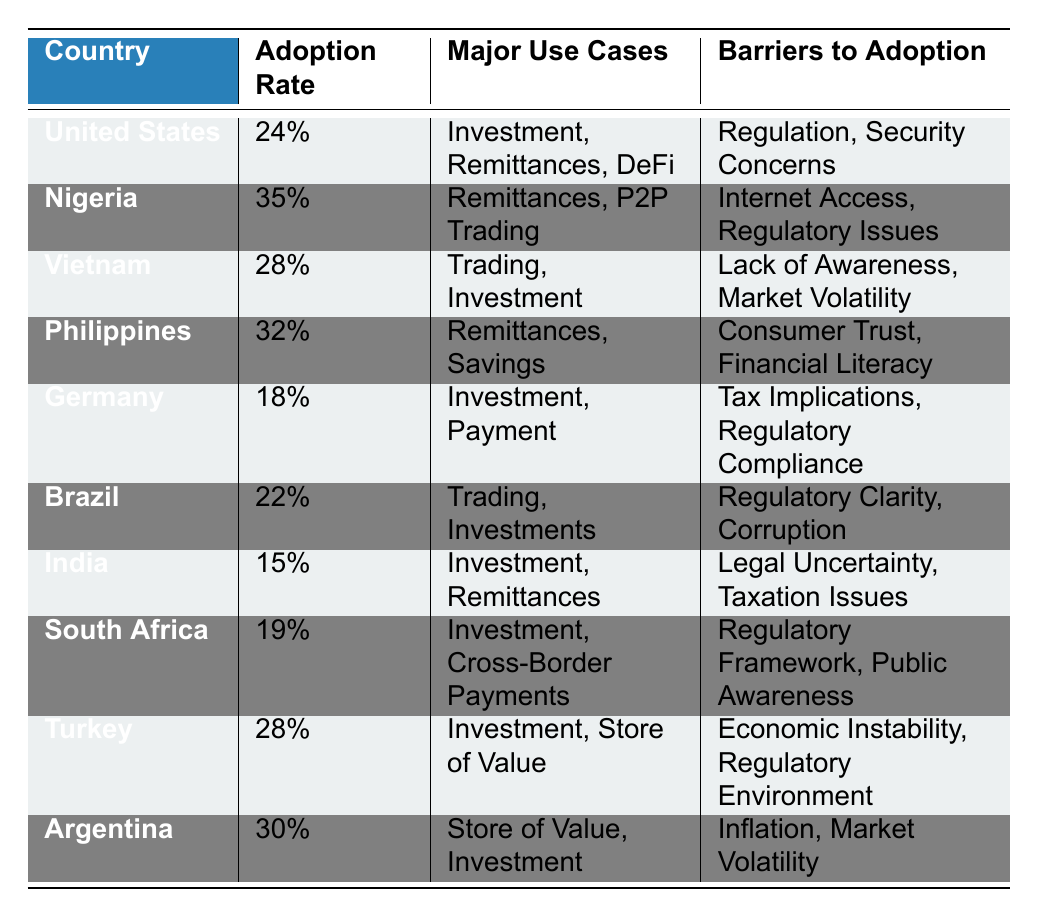What is the adoption rate of Nigeria? According to the table, Nigeria has an adoption rate listed as 35%.
Answer: 35% Which country has the highest adoption rate? The table shows Nigeria with the highest adoption rate of 35%.
Answer: Nigeria What are the major use cases for the Philippines? From the table, the major use cases for the Philippines are Remittances and Savings.
Answer: Remittances, Savings What is the difference in adoption rates between Argentina and India? Argentina's adoption rate is 30% and India's is 15%. The difference is calculated as 30% - 15% = 15%.
Answer: 15% Is the adoption rate in Germany greater than that in Turkey? The adoption rate in Germany is 18% while Turkey has an adoption rate of 28%. Since 18% is less than 28%, the statement is false.
Answer: No Which countries face barriers related to regulation? The countries facing barriers related to regulation, as per the table, are the United States, Brazil, and Turkey. This can be confirmed by checking the barriers listed for each country.
Answer: United States, Brazil, Turkey What is the average adoption rate of countries listed with an adoption rate above 20%? The countries with an adoption rate above 20% are Nigeria (35%), Philippines (32%), Vietnam (28%), Turkey (28%), and Argentina (30%). Their total is 35% + 32% + 28% + 28% + 30% = 153%. There are 5 countries, so the average is 153% / 5 = 30.6%.
Answer: 30.6% Does India have more major use cases than South Africa? India lists two major use cases (Investment and Remittances), and South Africa also lists two (Investment and Cross-Border Payments). Therefore, both have the same number of major use cases, making the statement false.
Answer: No Which country's barriers include security concerns? The table indicates that the United States has "Security Concerns" listed as one of its barriers to adoption.
Answer: United States 